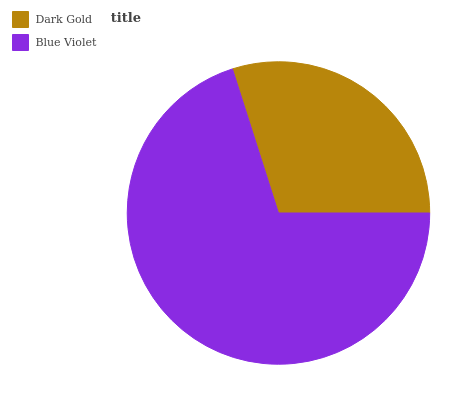Is Dark Gold the minimum?
Answer yes or no. Yes. Is Blue Violet the maximum?
Answer yes or no. Yes. Is Blue Violet the minimum?
Answer yes or no. No. Is Blue Violet greater than Dark Gold?
Answer yes or no. Yes. Is Dark Gold less than Blue Violet?
Answer yes or no. Yes. Is Dark Gold greater than Blue Violet?
Answer yes or no. No. Is Blue Violet less than Dark Gold?
Answer yes or no. No. Is Blue Violet the high median?
Answer yes or no. Yes. Is Dark Gold the low median?
Answer yes or no. Yes. Is Dark Gold the high median?
Answer yes or no. No. Is Blue Violet the low median?
Answer yes or no. No. 